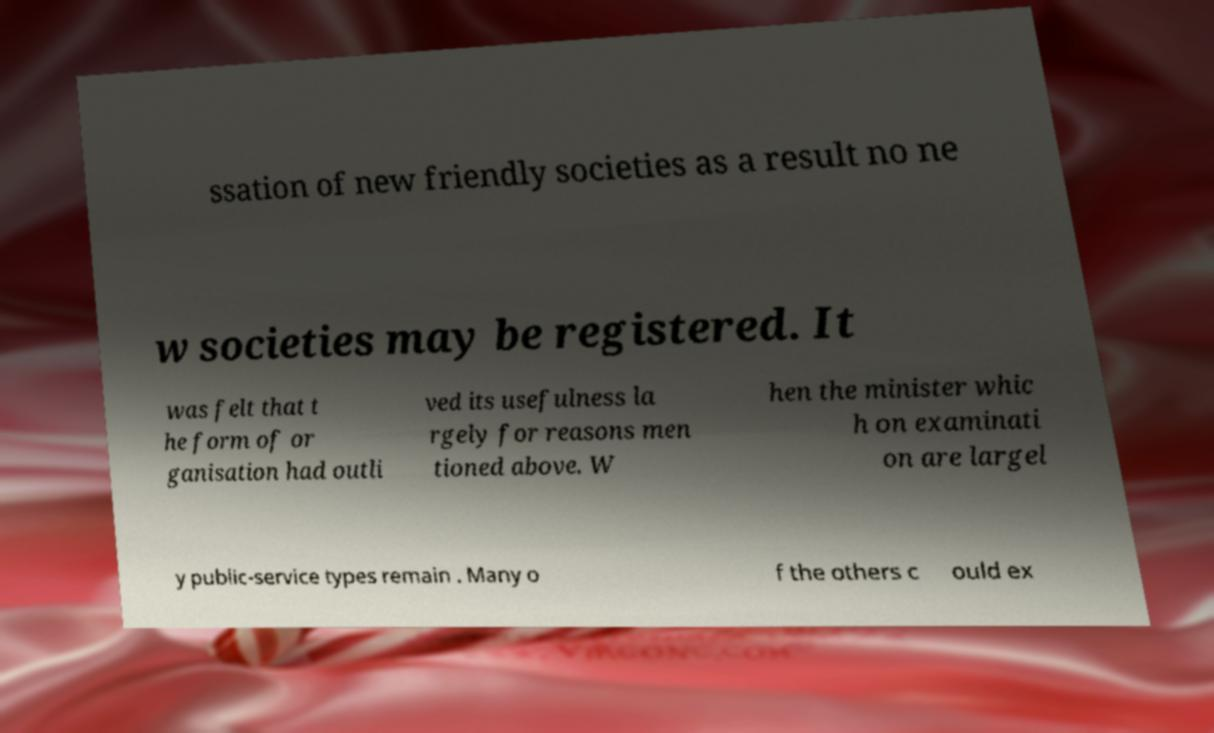For documentation purposes, I need the text within this image transcribed. Could you provide that? ssation of new friendly societies as a result no ne w societies may be registered. It was felt that t he form of or ganisation had outli ved its usefulness la rgely for reasons men tioned above. W hen the minister whic h on examinati on are largel y public-service types remain . Many o f the others c ould ex 